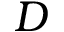Convert formula to latex. <formula><loc_0><loc_0><loc_500><loc_500>D</formula> 